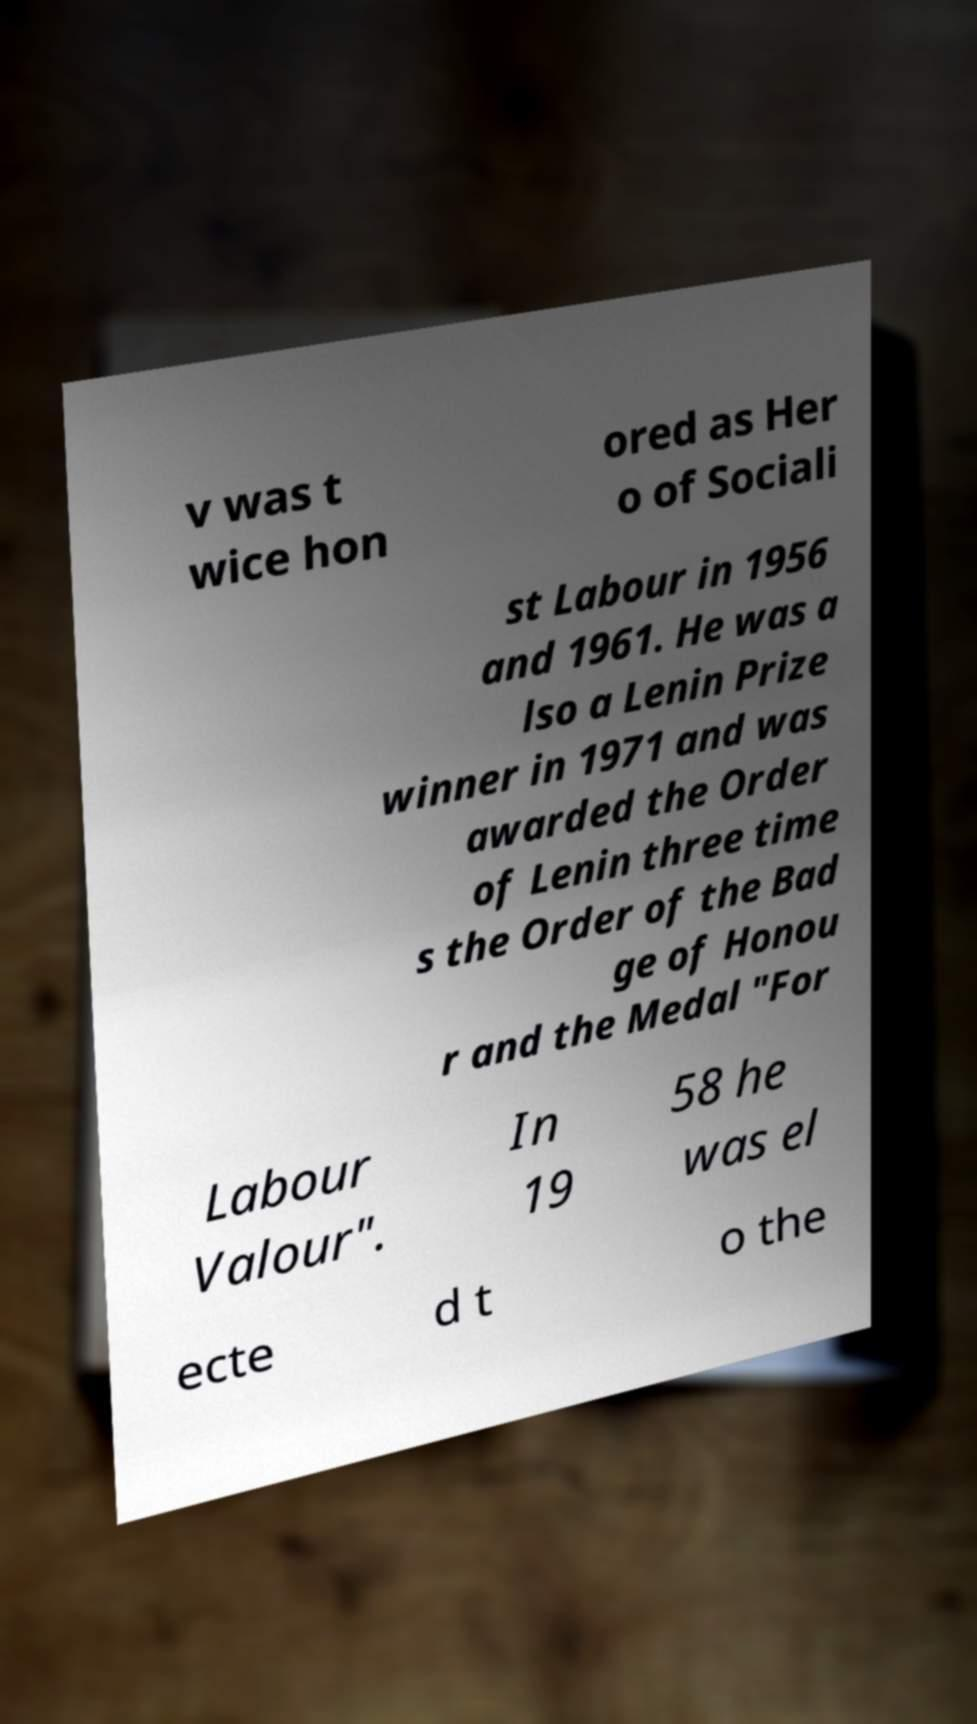For documentation purposes, I need the text within this image transcribed. Could you provide that? v was t wice hon ored as Her o of Sociali st Labour in 1956 and 1961. He was a lso a Lenin Prize winner in 1971 and was awarded the Order of Lenin three time s the Order of the Bad ge of Honou r and the Medal "For Labour Valour". In 19 58 he was el ecte d t o the 